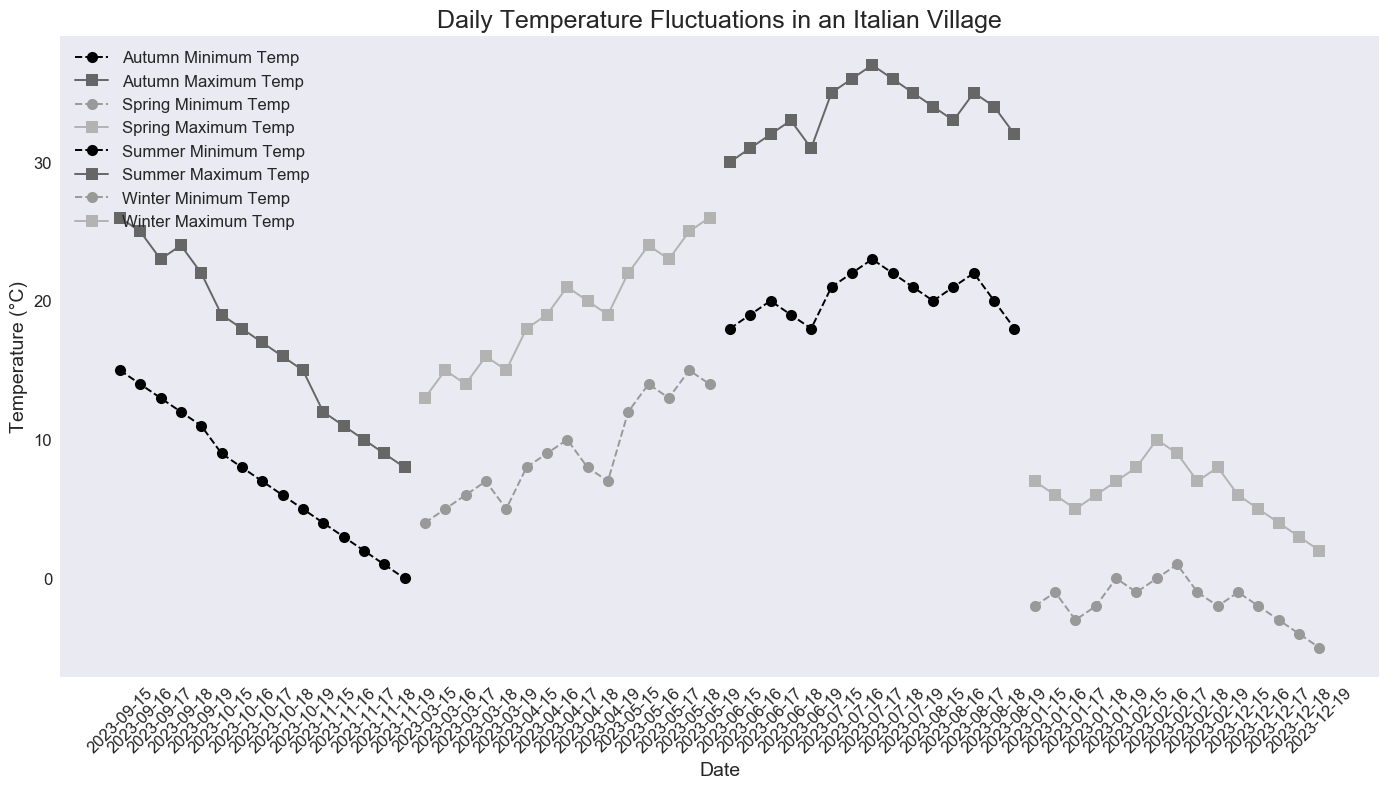Which season has the highest maximum temperature? Look at the lines representing the maximum temperatures for each season. The highest point among them represents the highest maximum temperature.
Answer: Summer During which month does Summer reach its peak temperature? Check the dates during the Summer season and locate the maximum temperature point.
Answer: July How much does the minimum temperature increase from Winter to Spring? Compare the minimum temperatures of the last Winter date (-5°C) and the first Spring date (4°C). Calculate the difference: 4 - (-5) = 4 + 5 = 9°C.
Answer: 9°C Compare the temperature range between Winter and Summer. Which one has a greater range? The temperature range is the difference between maximum and minimum temperatures for each season. Check the Winter's range (0—10°C: maximum - minimum = 10 - (-5) = 15) and Summer's range (18—37°C: maximum - minimum = 37 - 18 = 19). Summer has a greater range (19°C).
Answer: Summer On which month does Autumn have the lowest minimum temperature, and what is that temperature? Look at Autumn's minimum temperature line and find the lowest point. It happens in November, with a minimum temperature of 0°C.
Answer: November, 0°C What is the difference between the maximum temperature in Spring and Autumn? Locate the highest maximum temperature in Spring (26°C) and the highest in Autumn (26°C) and calculate the difference: 26 - 26 = 0°C.
Answer: 0°C Is there any overlap in temperatures between Winter and Spring? Compare the minimum and maximum temperatures of Winter (range: -5°C to 10°C) and Spring (4°C to 26°C). The overlapping range is from 4°C to 10°C.
Answer: Yes How does the minimum temperature trend from September to November in Autumn? Observe the minimum temperature line for Autumn from September (15°C) to November (0°C). The trend shows a consistent decrease.
Answer: Decreasing Which season exhibits the smallest fluctuation in daily temperatures? Check the ranges (Max-Min) for each season. Winter has the range 7°C (-5°C to 10°C), Spring 22°C (4°C to 26°C), Summer 19°C (18°C to 37°C), Autumn 26°C (0°C to 26°C). Winter has the smallest fluctuation.
Answer: Winter 